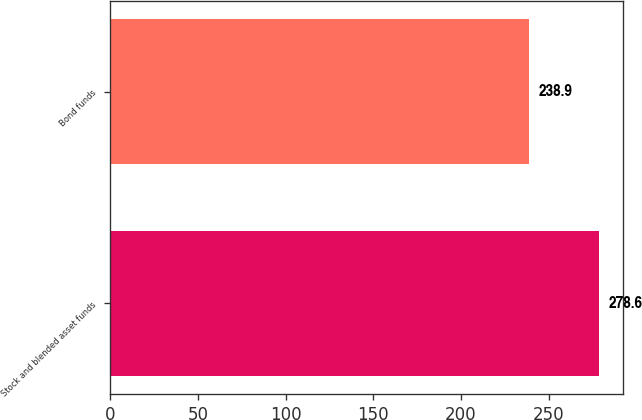<chart> <loc_0><loc_0><loc_500><loc_500><bar_chart><fcel>Stock and blended asset funds<fcel>Bond funds<nl><fcel>278.6<fcel>238.9<nl></chart> 